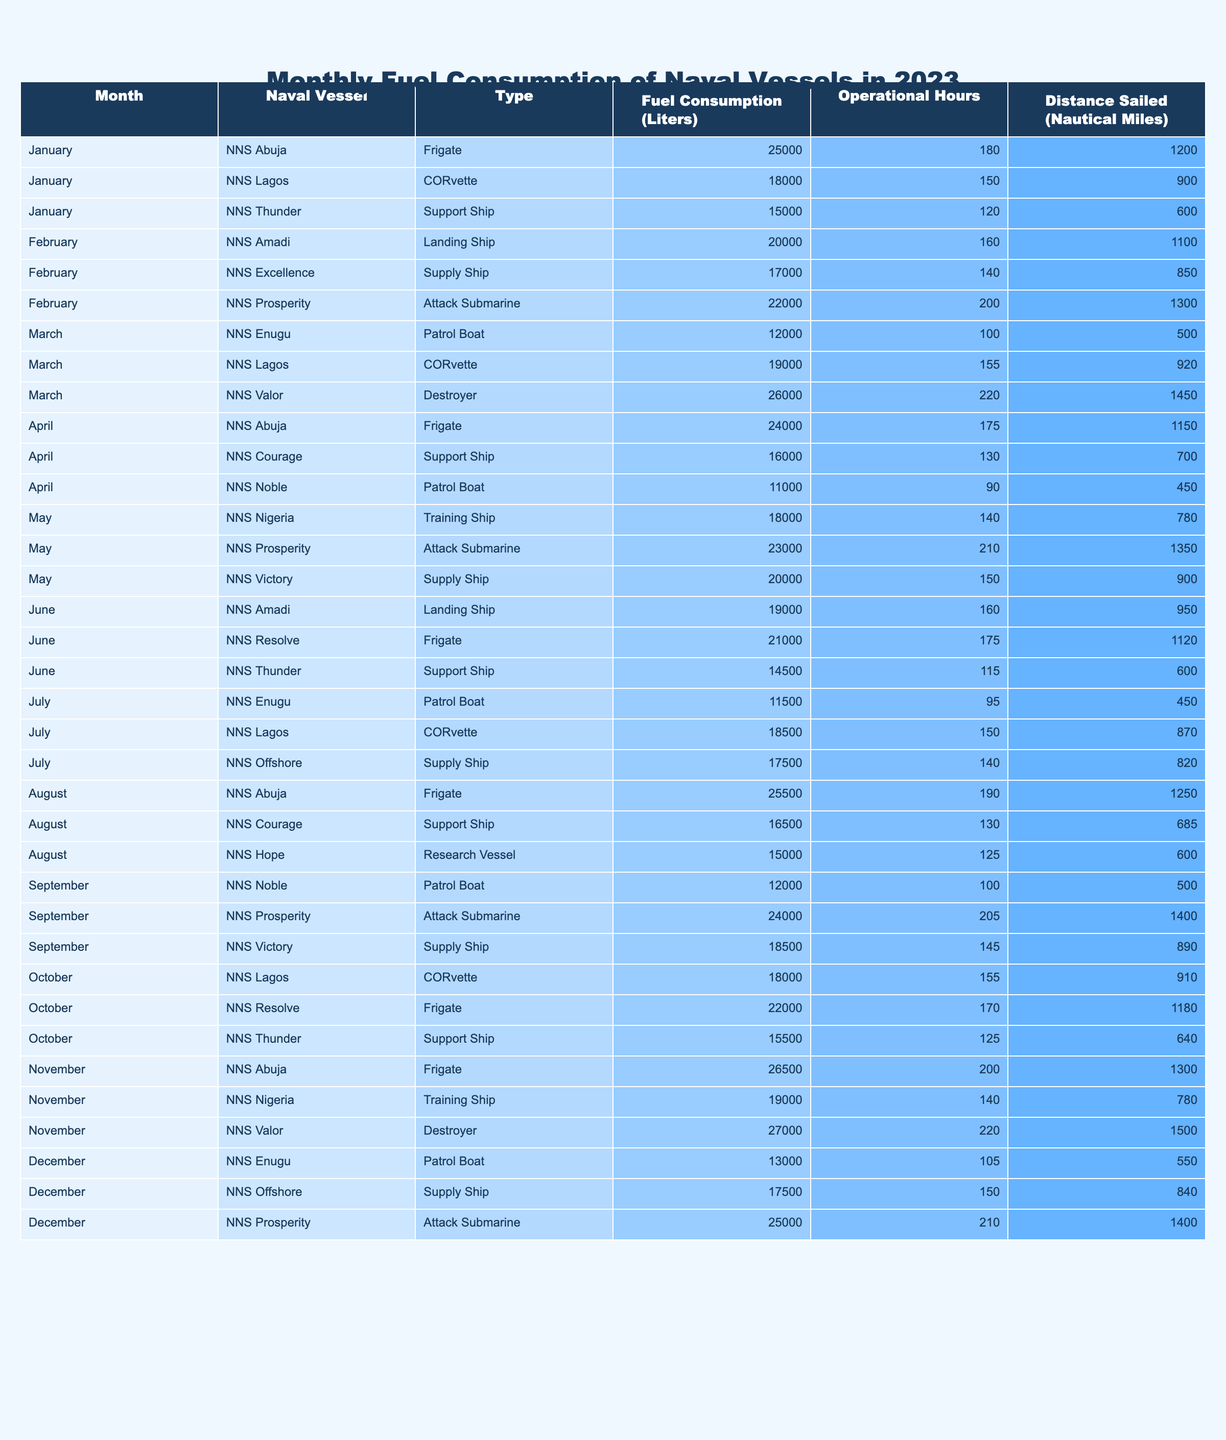What is the fuel consumption of NNS Abuja in November? In the table, I look under the month of November for NNS Abuja and find that its fuel consumption is listed as 26,500 liters.
Answer: 26,500 liters Which naval vessel had the highest fuel consumption in March? I check the fuel consumption values for all vessels in March, and I see that NNS Valor consumed 26,000 liters, which is higher than all others listed for that month.
Answer: NNS Valor What is the total fuel consumption of all attack submarines for the year? I go through the table and sum the fuel consumptions of the attack submarines: 22,000 (February) + 23,000 (May) + 24,000 (September) + 25,000 (December) = 94,000 liters.
Answer: 94,000 liters How many operational hours did NNS Thunder utilize throughout the year? I scan the table for all entries of NNS Thunder and add its operational hours: 120 (January) + 115 (June) + 125 (October) = 360 hours.
Answer: 360 hours Did any naval vessels have a fuel consumption of over 25,000 liters in August? I check the table for August to see if any vessels exceed 25,000 liters. NNS Abuja shows a consumption of 25,500 liters, so the answer is yes.
Answer: Yes What is the average fuel consumption of the frigates throughout the year? I list the fuel consumption for frigates: 25,000 (January), 24,000 (April), 21,000 (June), 25,500 (August), 22,000 (October), 26,500 (November). The total is 144,000 liters, and there are 6 entries, so the average is 144,000 / 6 = 24,000 liters.
Answer: 24,000 liters Which month had the lowest fuel consumption across all ships? I examine the table month by month for the total consumption figures. In December, NNS Enugu consumed the least at 13,000 liters while other ships consumed more. Summing all vessels' consumption also indicates December has lower totals than others.
Answer: December What is the difference in fuel consumption between NNS Lagos in January and October? I note the consumption of NNS Lagos in both months: January is 18,000 liters, and October is also 18,000 liters. The difference is 18,000 - 18,000 = 0 liters.
Answer: 0 liters How many hours did the naval vessels operate in total during May? I identify the operational hours recorded in May: 210 (Prosperity) + 140 (Nigeria) + 150 (Victory) = 500 hours of operation for that month.
Answer: 500 hours Is it true that NNS Nigeria consumed more fuel than NNS Courage in April? Checking the table, NNS Nigeria does not have any recorded fuel consumption in April, while NNS Courage shows 16,000 liters. So, it is true that NNS Courage consumed more fuel.
Answer: Yes 